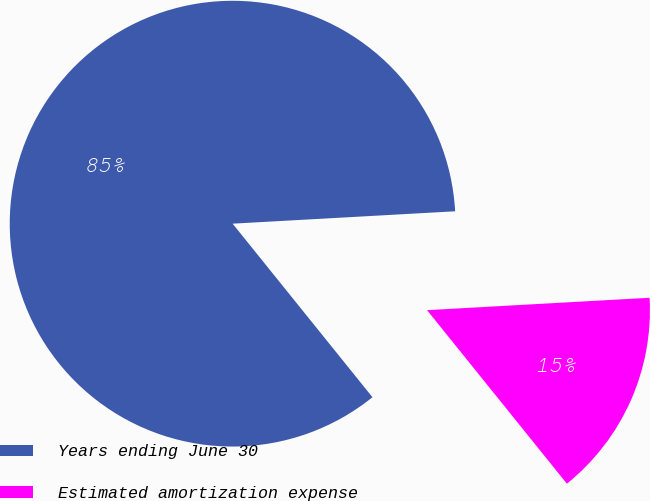Convert chart. <chart><loc_0><loc_0><loc_500><loc_500><pie_chart><fcel>Years ending June 30<fcel>Estimated amortization expense<nl><fcel>84.91%<fcel>15.09%<nl></chart> 